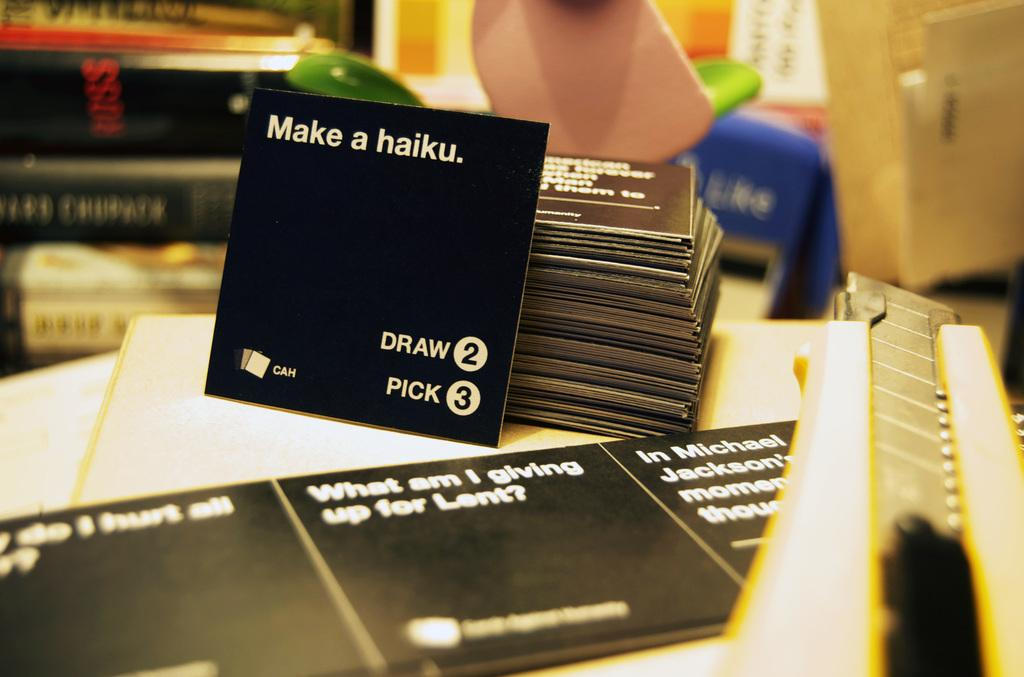<image>
Render a clear and concise summary of the photo. Placards in black give suggestions such as make a haiku. 